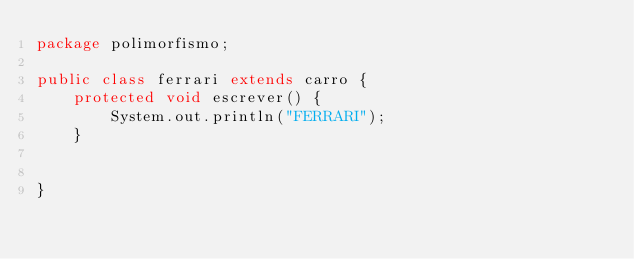<code> <loc_0><loc_0><loc_500><loc_500><_Java_>package polimorfismo;

public class ferrari extends carro {
	protected void escrever() {
		System.out.println("FERRARI");
	}


}
</code> 